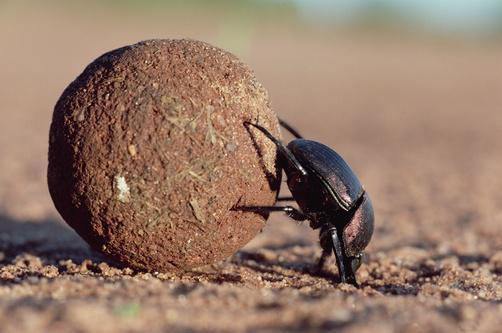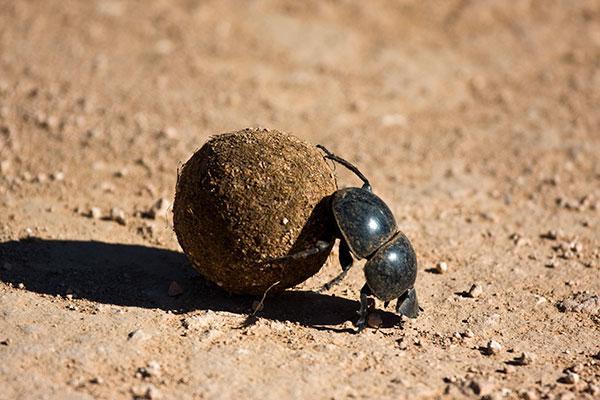The first image is the image on the left, the second image is the image on the right. For the images displayed, is the sentence "At least one of the beetles does not have any of its feet touching the ground." factually correct? Answer yes or no. No. The first image is the image on the left, the second image is the image on the right. Analyze the images presented: Is the assertion "Each image contains exactly one brown ball and one beetle, and the beetle in the righthand image has its front legs on the ground." valid? Answer yes or no. Yes. 